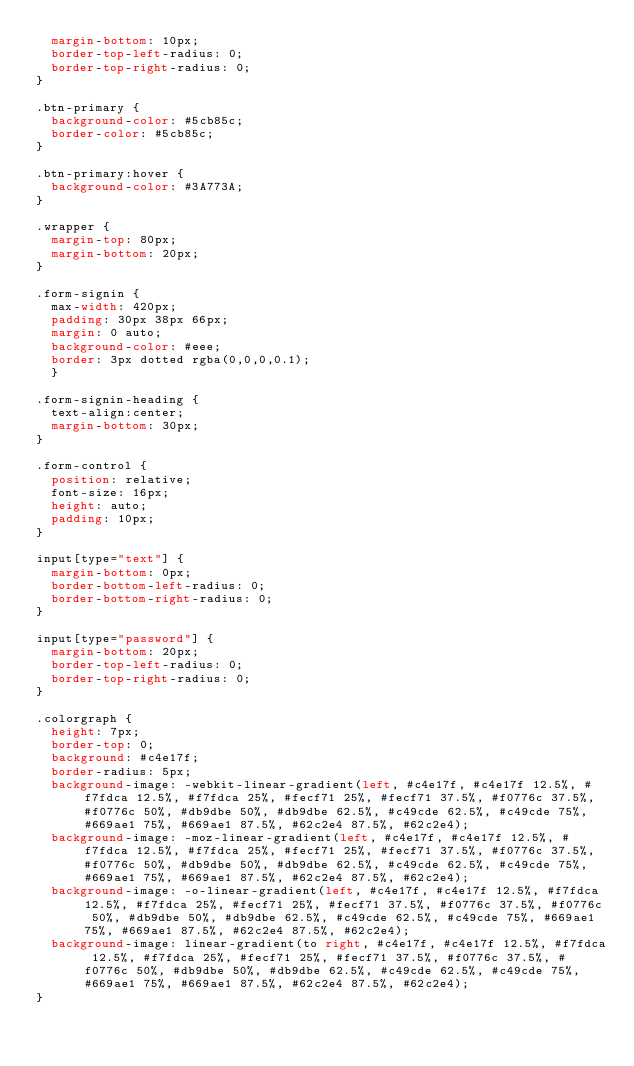<code> <loc_0><loc_0><loc_500><loc_500><_CSS_>  margin-bottom: 10px;
  border-top-left-radius: 0;
  border-top-right-radius: 0;
}

.btn-primary {
  background-color: #5cb85c; 
  border-color: #5cb85c;
}

.btn-primary:hover {
  background-color: #3A773A;
}

.wrapper {    
  margin-top: 80px;
  margin-bottom: 20px;
}

.form-signin {
  max-width: 420px;
  padding: 30px 38px 66px;
  margin: 0 auto;
  background-color: #eee;
  border: 3px dotted rgba(0,0,0,0.1);  
  }

.form-signin-heading {
  text-align:center;
  margin-bottom: 30px;
}

.form-control {
  position: relative;
  font-size: 16px;
  height: auto;
  padding: 10px;
}

input[type="text"] {
  margin-bottom: 0px;
  border-bottom-left-radius: 0;
  border-bottom-right-radius: 0;
}

input[type="password"] {
  margin-bottom: 20px;
  border-top-left-radius: 0;
  border-top-right-radius: 0;
}

.colorgraph {
  height: 7px;
  border-top: 0;
  background: #c4e17f;
  border-radius: 5px;
  background-image: -webkit-linear-gradient(left, #c4e17f, #c4e17f 12.5%, #f7fdca 12.5%, #f7fdca 25%, #fecf71 25%, #fecf71 37.5%, #f0776c 37.5%, #f0776c 50%, #db9dbe 50%, #db9dbe 62.5%, #c49cde 62.5%, #c49cde 75%, #669ae1 75%, #669ae1 87.5%, #62c2e4 87.5%, #62c2e4);
  background-image: -moz-linear-gradient(left, #c4e17f, #c4e17f 12.5%, #f7fdca 12.5%, #f7fdca 25%, #fecf71 25%, #fecf71 37.5%, #f0776c 37.5%, #f0776c 50%, #db9dbe 50%, #db9dbe 62.5%, #c49cde 62.5%, #c49cde 75%, #669ae1 75%, #669ae1 87.5%, #62c2e4 87.5%, #62c2e4);
  background-image: -o-linear-gradient(left, #c4e17f, #c4e17f 12.5%, #f7fdca 12.5%, #f7fdca 25%, #fecf71 25%, #fecf71 37.5%, #f0776c 37.5%, #f0776c 50%, #db9dbe 50%, #db9dbe 62.5%, #c49cde 62.5%, #c49cde 75%, #669ae1 75%, #669ae1 87.5%, #62c2e4 87.5%, #62c2e4);
  background-image: linear-gradient(to right, #c4e17f, #c4e17f 12.5%, #f7fdca 12.5%, #f7fdca 25%, #fecf71 25%, #fecf71 37.5%, #f0776c 37.5%, #f0776c 50%, #db9dbe 50%, #db9dbe 62.5%, #c49cde 62.5%, #c49cde 75%, #669ae1 75%, #669ae1 87.5%, #62c2e4 87.5%, #62c2e4);
}</code> 